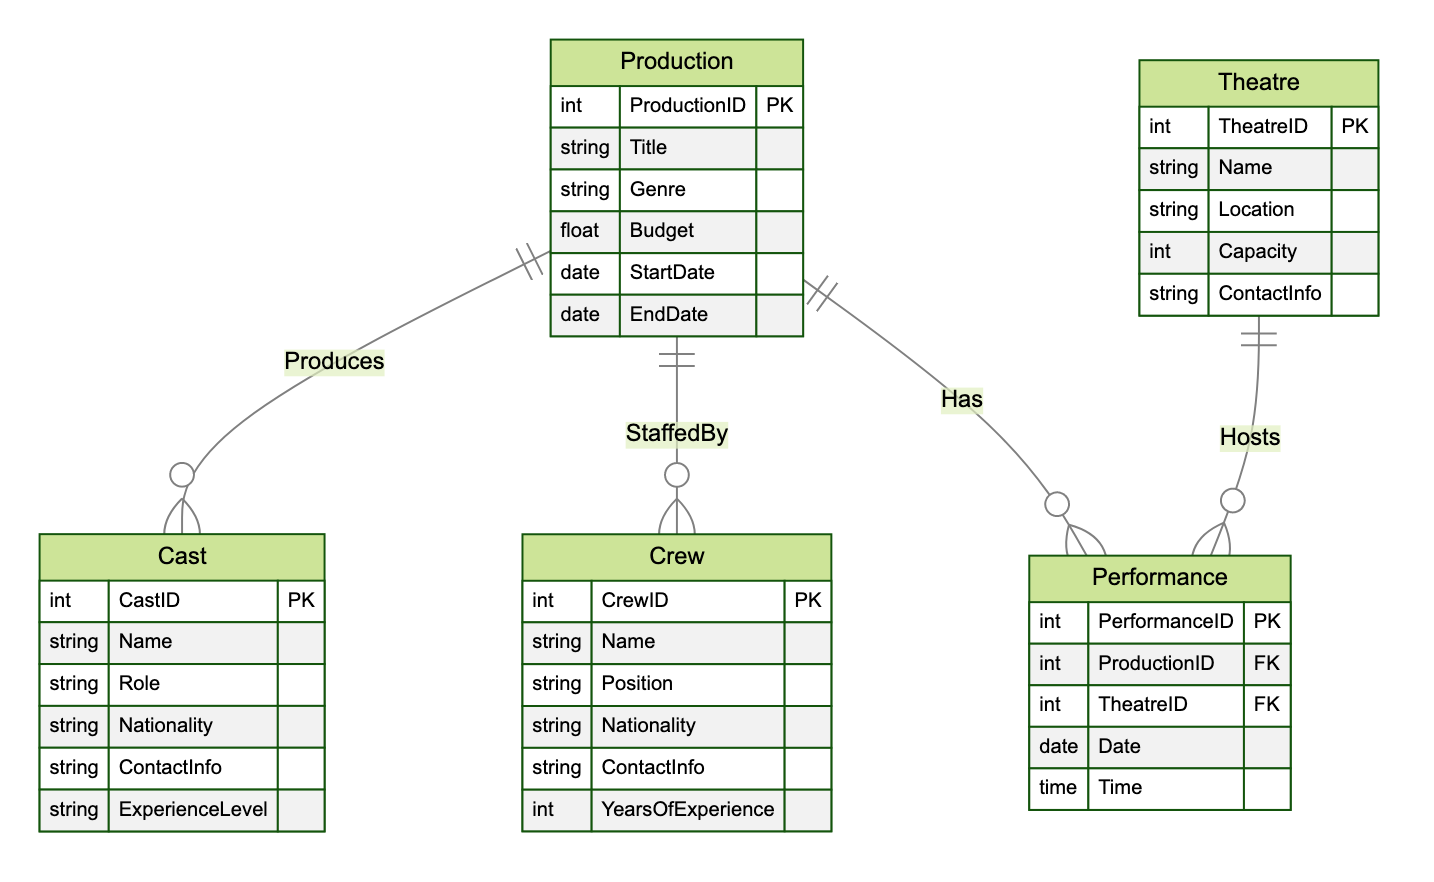What is the maximum number of Cast members for a single Production? The relationship "Produces" between Production and Cast is a "OneToMany" relationship. This means a single Production can have multiple Cast members associated with it. Therefore, the maximum number is not explicitly defined; it depends on each individual Production's setup but is at least one.
Answer: Multiple How many attributes does the Crew entity have? The Crew entity has six attributes listed: CrewID, Name, Position, Nationality, Contact Info, and Years of Experience. This can be directly counted by examining the attributes under the Crew node.
Answer: Six Which entities are directly related to the Theatre entity? The Theatre entity is directly related to the Performance entity through the "Hosts" relationship. The relationship type is "OneToMany", indicating that one Theatre can host multiple Performances. This information is found by looking for the relationships stemming from the Theatre node.
Answer: Performance What relationship connects Production and Crew? The relationship that connects Production and Crew is called "StaffedBy". This can be found by identifying the relationships that connect these two entities on the diagram.
Answer: StaffedBy How many entities are in the diagram? The diagram contains five entities: Production, Cast, Crew, Theatre, and Performance. This count can be derived by listing the entities present in the diagram and summing them.
Answer: Five What is the data type of the Budget attribute in the Production entity? The Budget attribute in the Production entity is of type float. This is classified by looking at the attribute list under the Production node and identifying the data type specified next to Budget.
Answer: Float What type of relationship exists between Production and Performance? The relationship between Production and Performance is established as "Has", and it is a "OneToMany" relationship, indicating one Production can have multiple Performances. This can be seen by identifying the relationship line connecting these entities.
Answer: OneToMany What attribute uniquely identifies a Cast member? A Cast member is uniquely identified by the CastID attribute. This is evident from the attributes listed under the Cast entity, where CastID is designated as the primary key (PK).
Answer: CastID What is the capacity attribute's data type in the Theatre entity? The Capacity attribute in the Theatre entity is of type integer, as noted in the attributes listed under the Theatre node.
Answer: Integer 